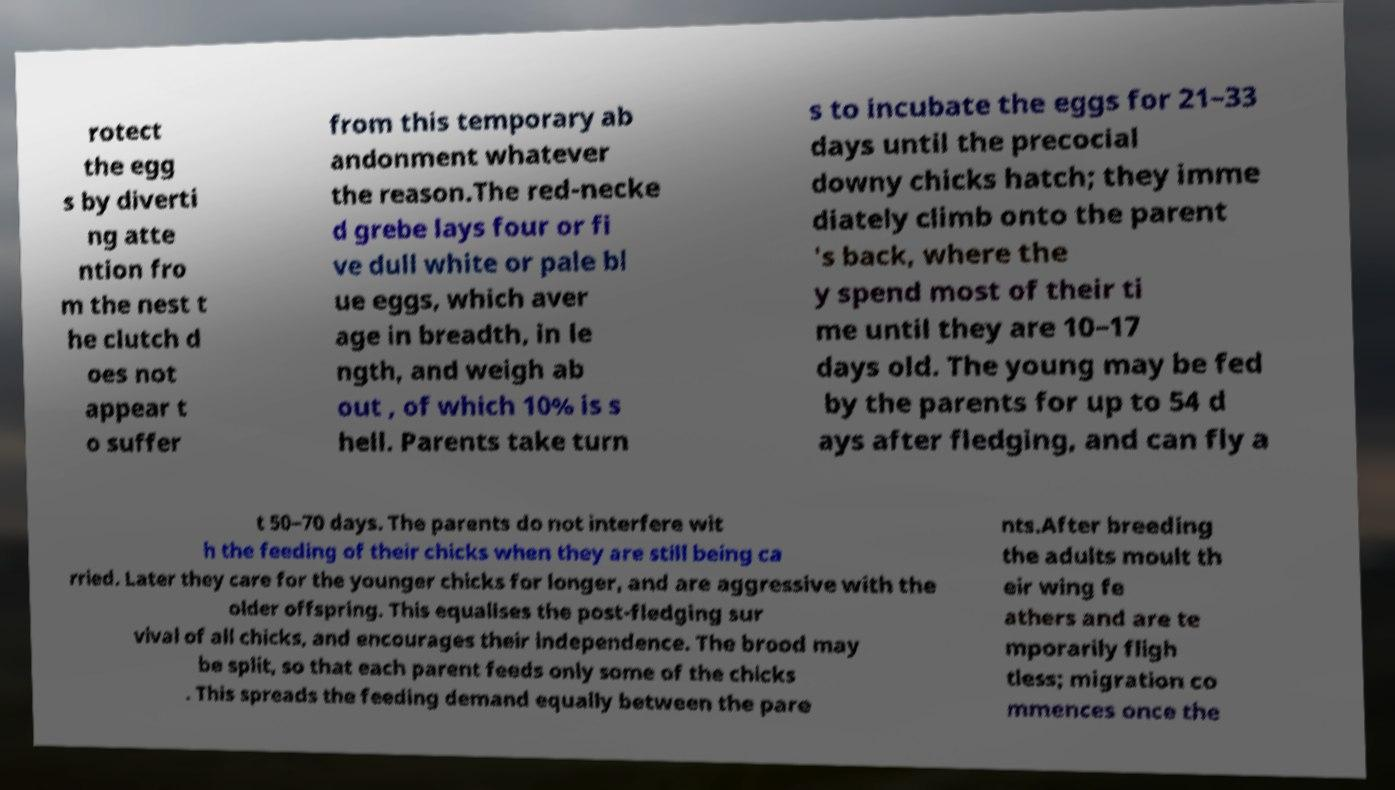What messages or text are displayed in this image? I need them in a readable, typed format. rotect the egg s by diverti ng atte ntion fro m the nest t he clutch d oes not appear t o suffer from this temporary ab andonment whatever the reason.The red-necke d grebe lays four or fi ve dull white or pale bl ue eggs, which aver age in breadth, in le ngth, and weigh ab out , of which 10% is s hell. Parents take turn s to incubate the eggs for 21–33 days until the precocial downy chicks hatch; they imme diately climb onto the parent 's back, where the y spend most of their ti me until they are 10–17 days old. The young may be fed by the parents for up to 54 d ays after fledging, and can fly a t 50–70 days. The parents do not interfere wit h the feeding of their chicks when they are still being ca rried. Later they care for the younger chicks for longer, and are aggressive with the older offspring. This equalises the post-fledging sur vival of all chicks, and encourages their independence. The brood may be split, so that each parent feeds only some of the chicks . This spreads the feeding demand equally between the pare nts.After breeding the adults moult th eir wing fe athers and are te mporarily fligh tless; migration co mmences once the 